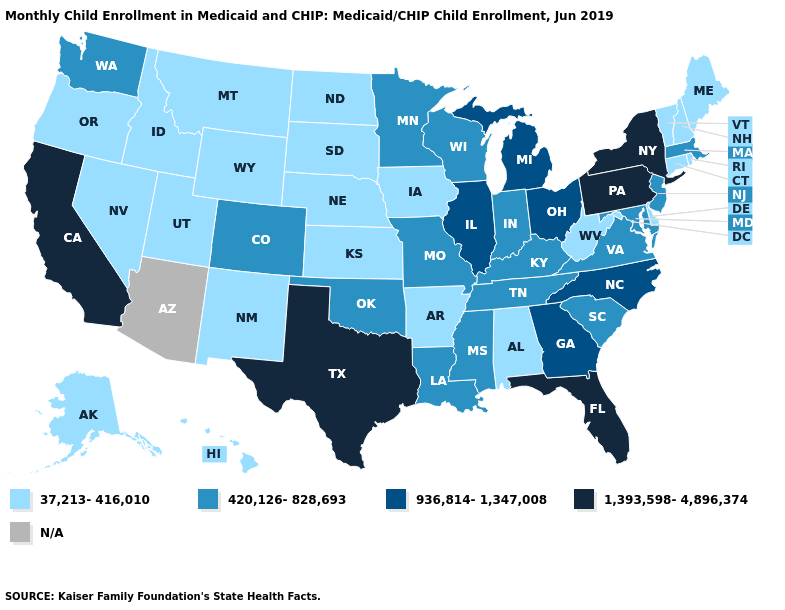Name the states that have a value in the range 420,126-828,693?
Keep it brief. Colorado, Indiana, Kentucky, Louisiana, Maryland, Massachusetts, Minnesota, Mississippi, Missouri, New Jersey, Oklahoma, South Carolina, Tennessee, Virginia, Washington, Wisconsin. Name the states that have a value in the range 1,393,598-4,896,374?
Quick response, please. California, Florida, New York, Pennsylvania, Texas. What is the value of Maryland?
Answer briefly. 420,126-828,693. Does Montana have the highest value in the USA?
Answer briefly. No. Does Wyoming have the lowest value in the West?
Keep it brief. Yes. What is the value of South Carolina?
Concise answer only. 420,126-828,693. Does Michigan have the highest value in the MidWest?
Keep it brief. Yes. Name the states that have a value in the range 936,814-1,347,008?
Short answer required. Georgia, Illinois, Michigan, North Carolina, Ohio. Name the states that have a value in the range 1,393,598-4,896,374?
Give a very brief answer. California, Florida, New York, Pennsylvania, Texas. Does the first symbol in the legend represent the smallest category?
Short answer required. Yes. What is the value of New Jersey?
Concise answer only. 420,126-828,693. What is the value of Kentucky?
Short answer required. 420,126-828,693. Does Massachusetts have the lowest value in the USA?
Be succinct. No. Name the states that have a value in the range N/A?
Concise answer only. Arizona. 